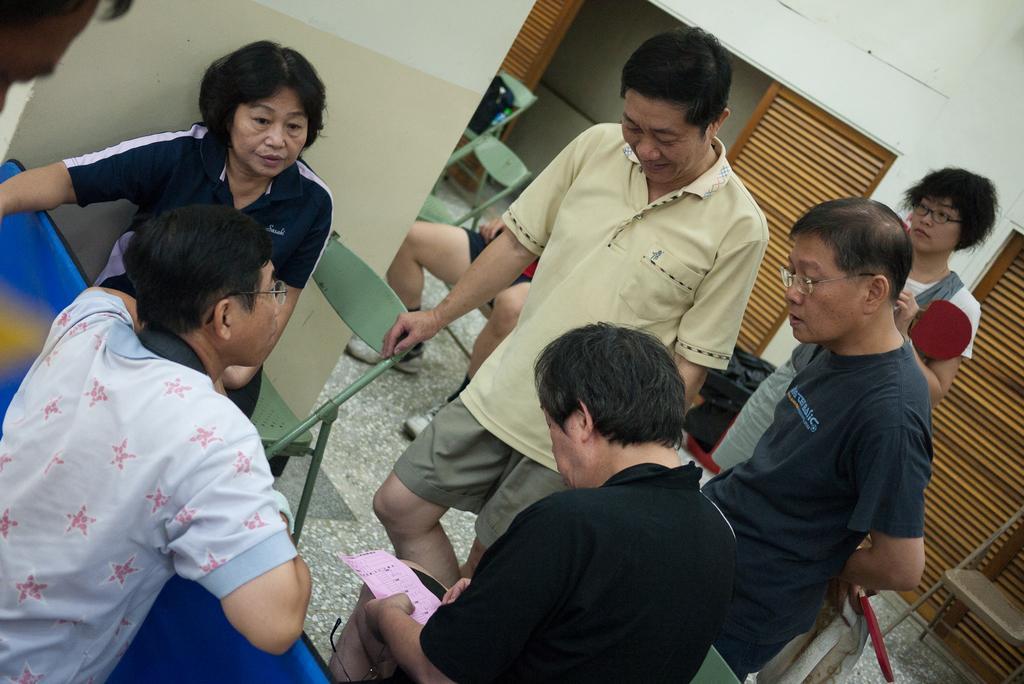In one or two sentences, can you explain what this image depicts? In this image, there are a few people. We can also see some chairs. We can see the ground and the wall. We can also see some wood. There are some black colored objects. 